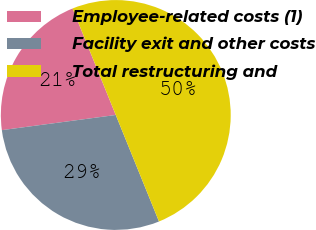<chart> <loc_0><loc_0><loc_500><loc_500><pie_chart><fcel>Employee-related costs (1)<fcel>Facility exit and other costs<fcel>Total restructuring and<nl><fcel>20.97%<fcel>29.03%<fcel>50.0%<nl></chart> 